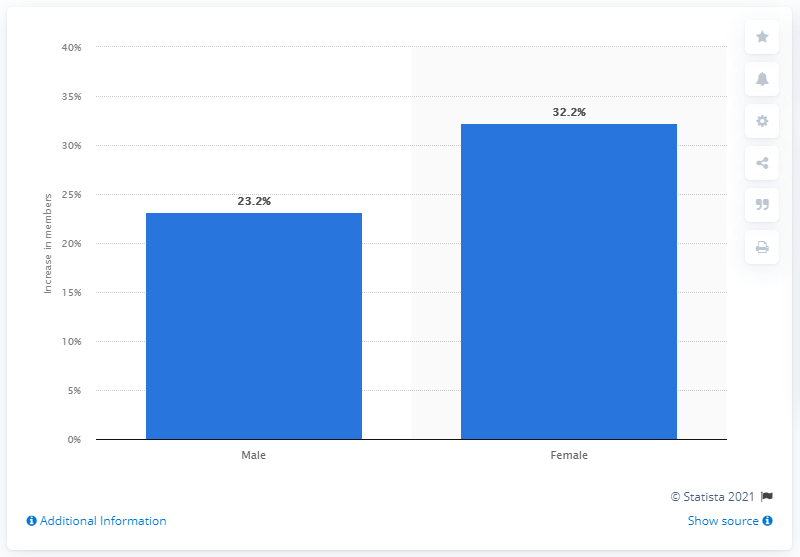Draw attention to some important aspects in this diagram. The number of female health and fitness club members increased by 32.2% between 2010 and 2019. The number of male gym-goers who visited the gym more often between 2010 and 2019 increased by 23.2%. 